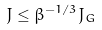<formula> <loc_0><loc_0><loc_500><loc_500>J \leq \beta ^ { - 1 / 3 } J _ { G }</formula> 